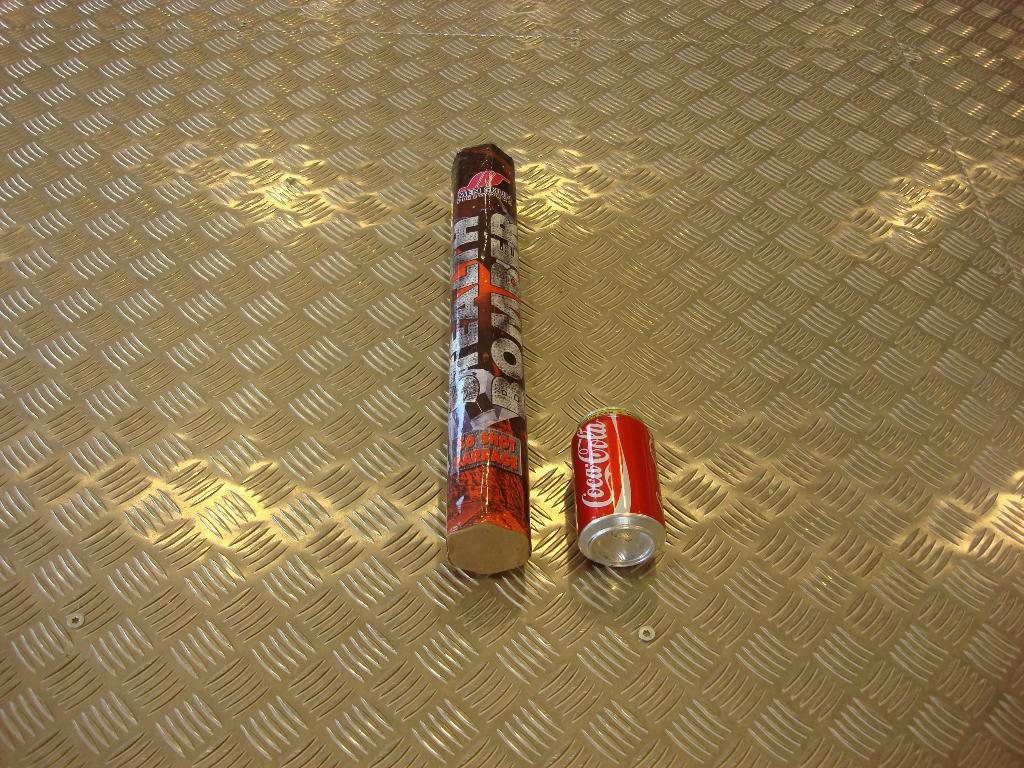<image>
Give a short and clear explanation of the subsequent image. a can of coca cola next to others 